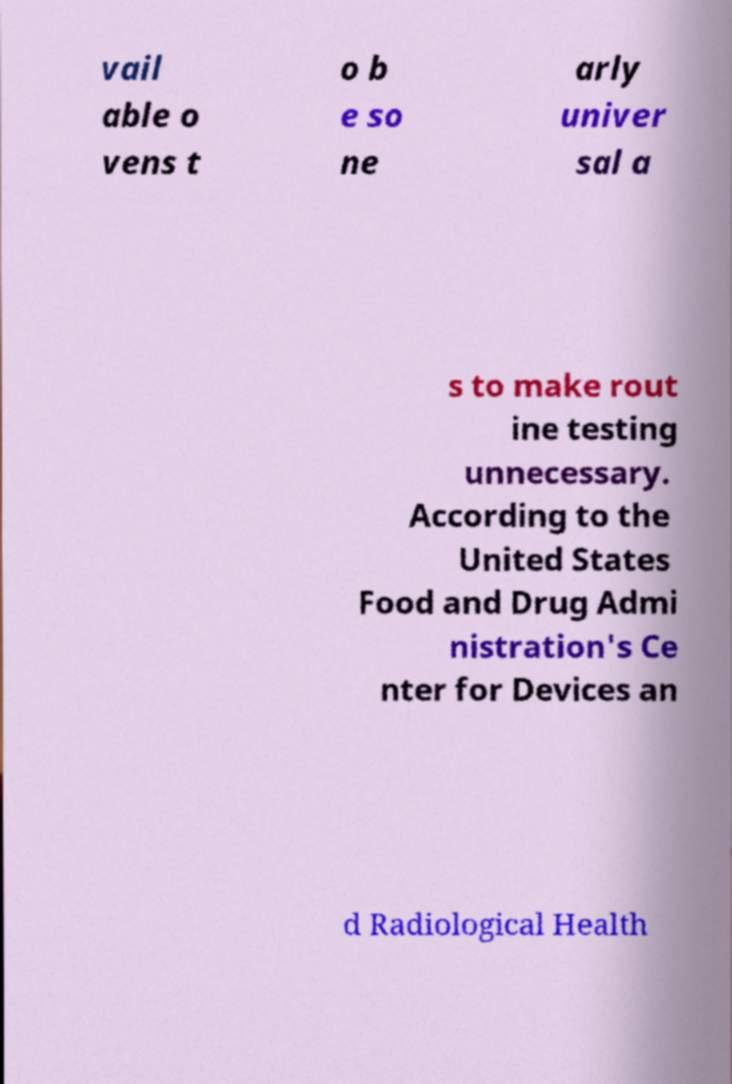Could you assist in decoding the text presented in this image and type it out clearly? vail able o vens t o b e so ne arly univer sal a s to make rout ine testing unnecessary. According to the United States Food and Drug Admi nistration's Ce nter for Devices an d Radiological Health 